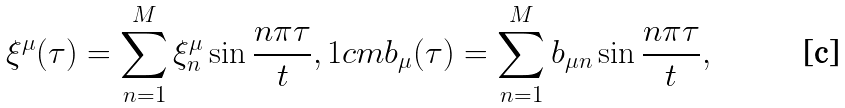<formula> <loc_0><loc_0><loc_500><loc_500>\xi ^ { \mu } ( \tau ) = \sum _ { n = 1 } ^ { M } \xi _ { n } ^ { \mu } \sin \frac { n \pi \tau } { t } , 1 c m b _ { \mu } ( \tau ) = \sum _ { n = 1 } ^ { M } b _ { \mu n } \sin \frac { n \pi \tau } { t } ,</formula> 